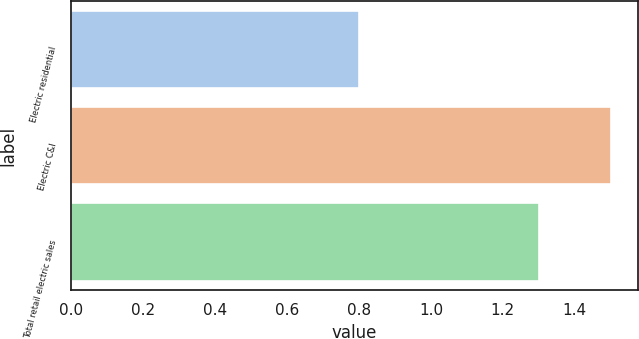Convert chart to OTSL. <chart><loc_0><loc_0><loc_500><loc_500><bar_chart><fcel>Electric residential<fcel>Electric C&I<fcel>Total retail electric sales<nl><fcel>0.8<fcel>1.5<fcel>1.3<nl></chart> 